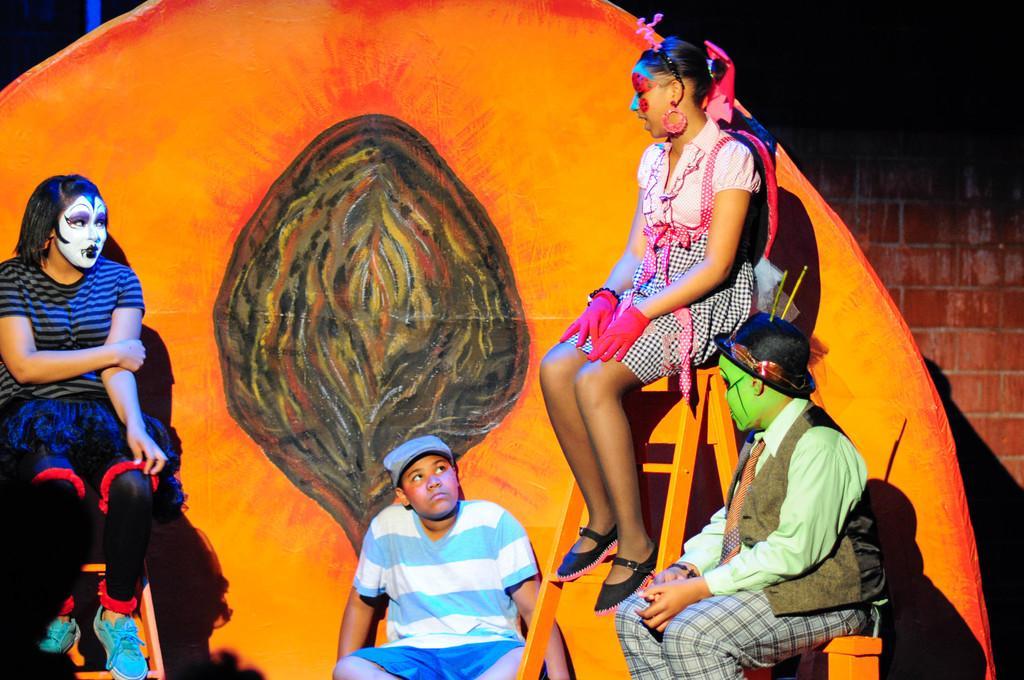Please provide a concise description of this image. In this picture we can see a group of people sitting and a painting on their faces and in the background we can see brick wall. 